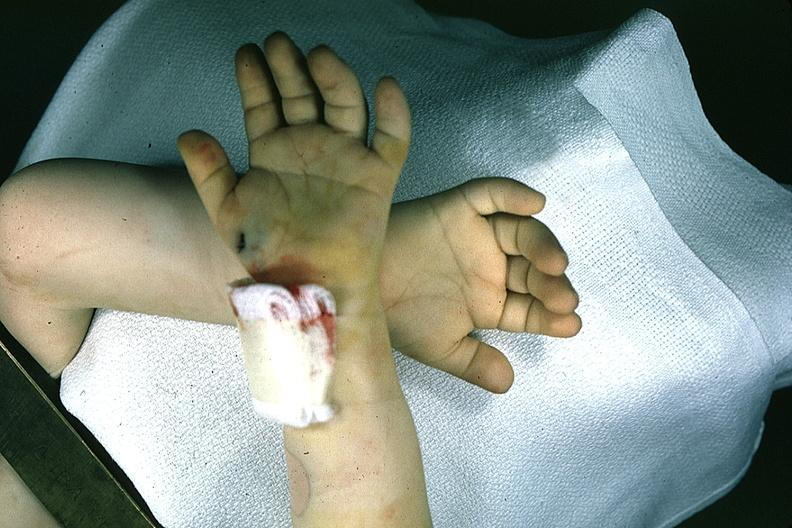what are present?
Answer the question using a single word or phrase. Extremities 